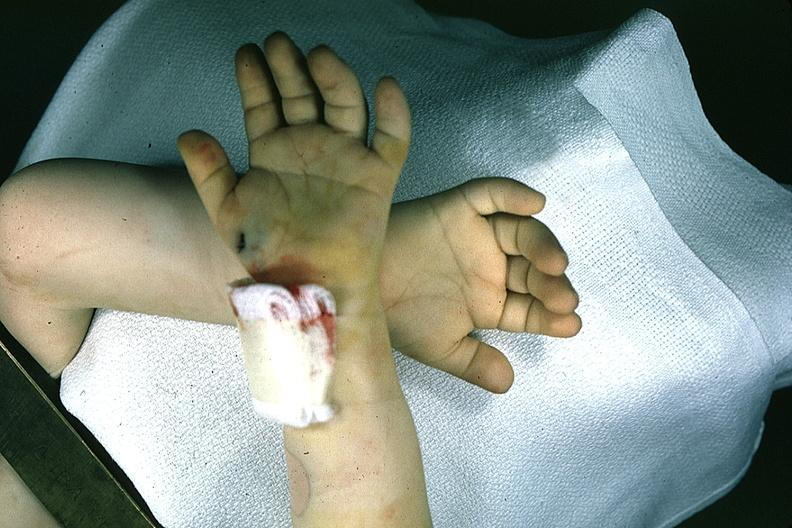what are present?
Answer the question using a single word or phrase. Extremities 